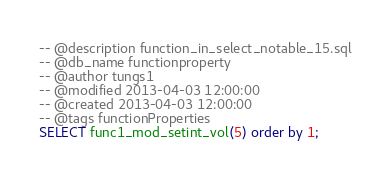<code> <loc_0><loc_0><loc_500><loc_500><_SQL_>-- @description function_in_select_notable_15.sql
-- @db_name functionproperty
-- @author tungs1
-- @modified 2013-04-03 12:00:00
-- @created 2013-04-03 12:00:00
-- @tags functionProperties 
SELECT func1_mod_setint_vol(5) order by 1; 
</code> 